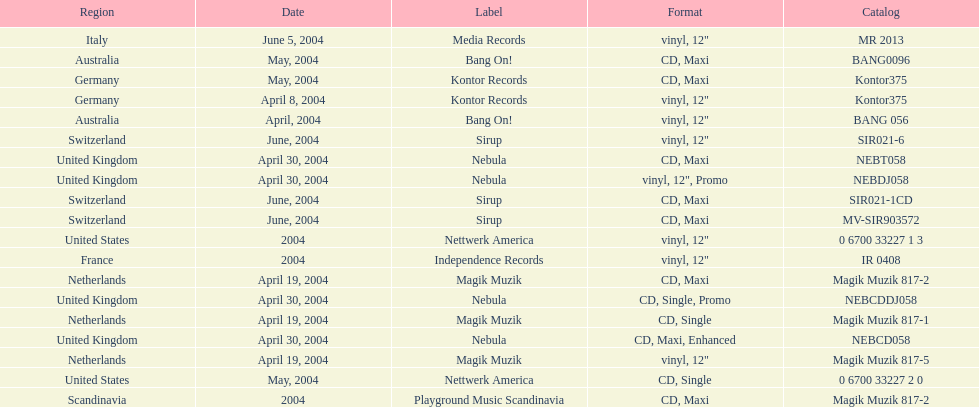What region is above australia? Germany. Could you parse the entire table as a dict? {'header': ['Region', 'Date', 'Label', 'Format', 'Catalog'], 'rows': [['Italy', 'June 5, 2004', 'Media Records', 'vinyl, 12"', 'MR 2013'], ['Australia', 'May, 2004', 'Bang On!', 'CD, Maxi', 'BANG0096'], ['Germany', 'May, 2004', 'Kontor Records', 'CD, Maxi', 'Kontor375'], ['Germany', 'April 8, 2004', 'Kontor Records', 'vinyl, 12"', 'Kontor375'], ['Australia', 'April, 2004', 'Bang On!', 'vinyl, 12"', 'BANG 056'], ['Switzerland', 'June, 2004', 'Sirup', 'vinyl, 12"', 'SIR021-6'], ['United Kingdom', 'April 30, 2004', 'Nebula', 'CD, Maxi', 'NEBT058'], ['United Kingdom', 'April 30, 2004', 'Nebula', 'vinyl, 12", Promo', 'NEBDJ058'], ['Switzerland', 'June, 2004', 'Sirup', 'CD, Maxi', 'SIR021-1CD'], ['Switzerland', 'June, 2004', 'Sirup', 'CD, Maxi', 'MV-SIR903572'], ['United States', '2004', 'Nettwerk America', 'vinyl, 12"', '0 6700 33227 1 3'], ['France', '2004', 'Independence Records', 'vinyl, 12"', 'IR 0408'], ['Netherlands', 'April 19, 2004', 'Magik Muzik', 'CD, Maxi', 'Magik Muzik 817-2'], ['United Kingdom', 'April 30, 2004', 'Nebula', 'CD, Single, Promo', 'NEBCDDJ058'], ['Netherlands', 'April 19, 2004', 'Magik Muzik', 'CD, Single', 'Magik Muzik 817-1'], ['United Kingdom', 'April 30, 2004', 'Nebula', 'CD, Maxi, Enhanced', 'NEBCD058'], ['Netherlands', 'April 19, 2004', 'Magik Muzik', 'vinyl, 12"', 'Magik Muzik 817-5'], ['United States', 'May, 2004', 'Nettwerk America', 'CD, Single', '0 6700 33227 2 0'], ['Scandinavia', '2004', 'Playground Music Scandinavia', 'CD, Maxi', 'Magik Muzik 817-2']]} 